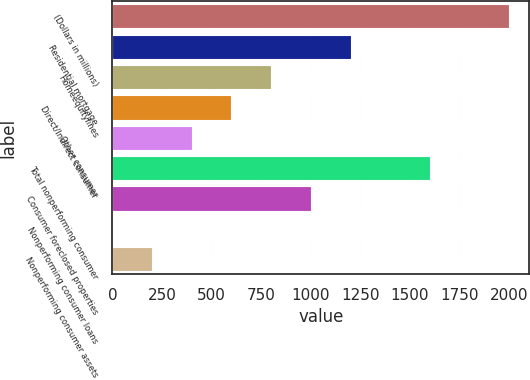Convert chart to OTSL. <chart><loc_0><loc_0><loc_500><loc_500><bar_chart><fcel>(Dollars in millions)<fcel>Residential mortgage<fcel>Homeequitylines<fcel>Direct/Indirect consumer<fcel>Other consumer<fcel>Total nonperforming consumer<fcel>Consumer foreclosed properties<fcel>Nonperforming consumer loans<fcel>Nonperforming consumer assets<nl><fcel>2002<fcel>1201.33<fcel>801.01<fcel>600.85<fcel>400.69<fcel>1601.65<fcel>1001.17<fcel>0.37<fcel>200.53<nl></chart> 